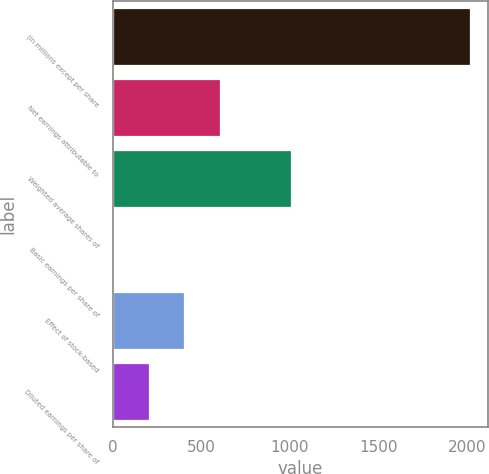Convert chart. <chart><loc_0><loc_0><loc_500><loc_500><bar_chart><fcel>(in millions except per share<fcel>Net earnings attributable to<fcel>Weighted average shares of<fcel>Basic earnings per share of<fcel>Effect of stock-based<fcel>Diluted earnings per share of<nl><fcel>2016<fcel>605.18<fcel>1008.27<fcel>0.55<fcel>403.64<fcel>202.1<nl></chart> 